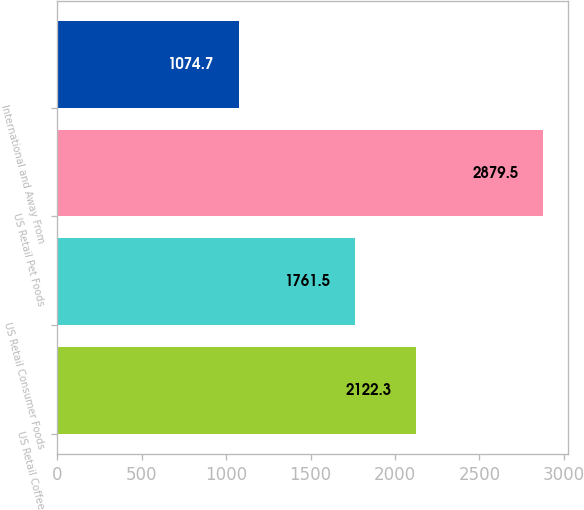<chart> <loc_0><loc_0><loc_500><loc_500><bar_chart><fcel>US Retail Coffee<fcel>US Retail Consumer Foods<fcel>US Retail Pet Foods<fcel>International and Away From<nl><fcel>2122.3<fcel>1761.5<fcel>2879.5<fcel>1074.7<nl></chart> 